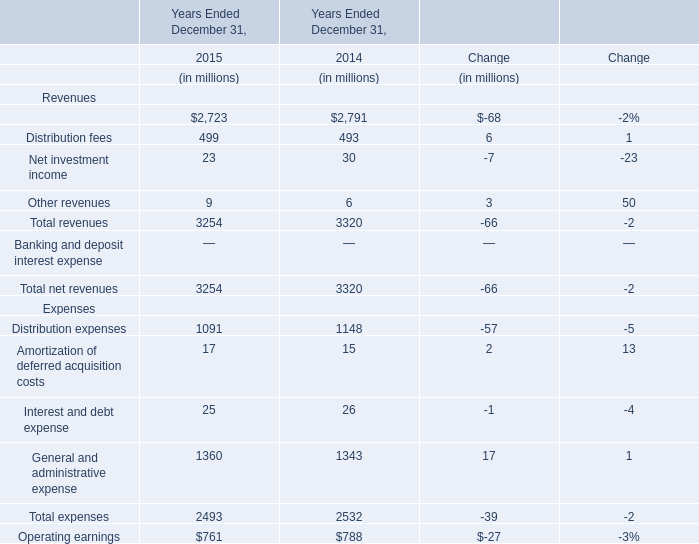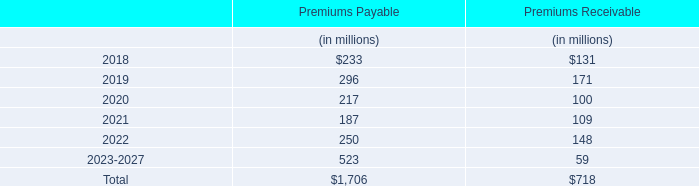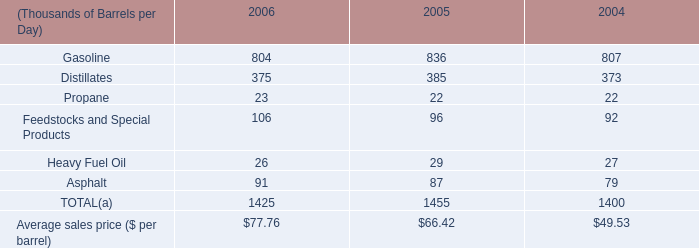In what year is Management and financial advice fees greater than 2750? 
Answer: 2014. 